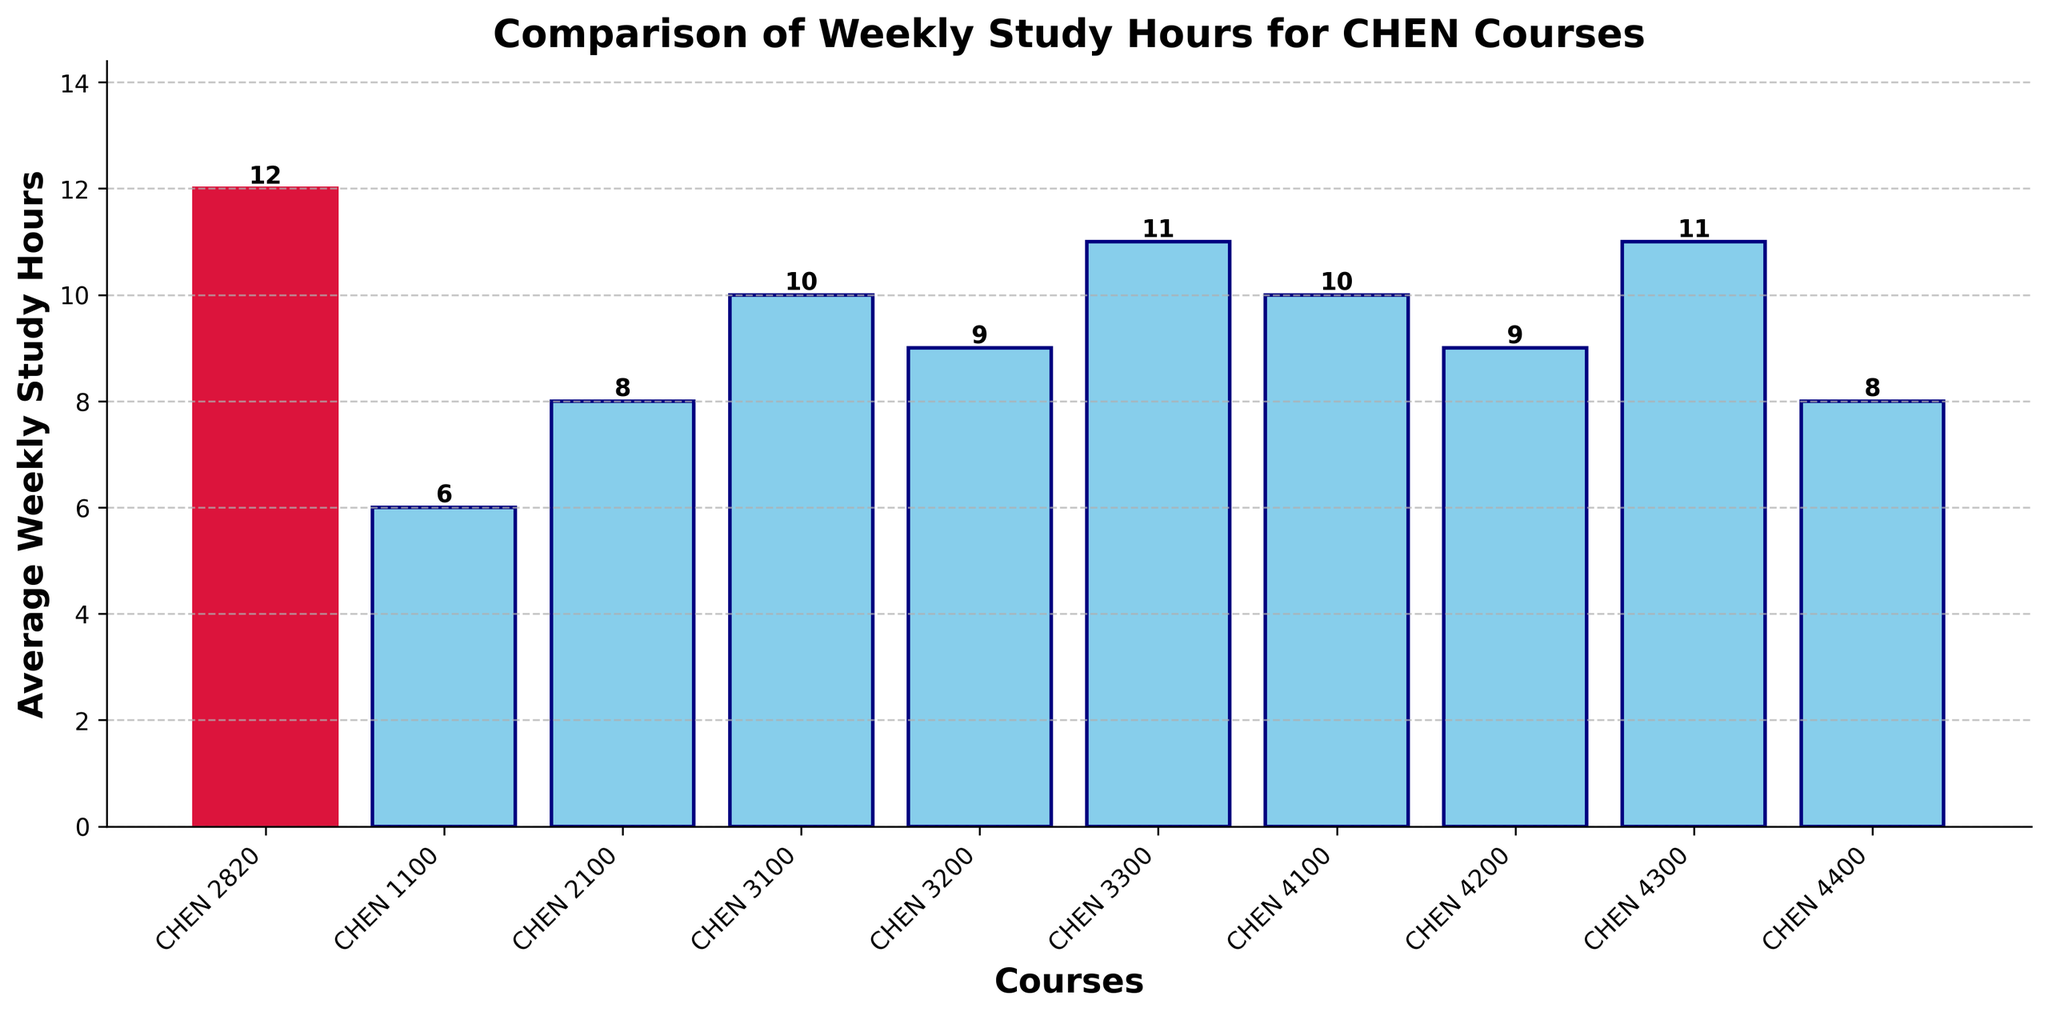What's the average number of study hours for CHEN 2100 and CHEN 4400 combined? Add the study hours of CHEN 2100 (8 hours) and CHEN 4400 (8 hours) to get 16 hours, then divide by 2 to get the average: 16/2 = 8 hours
Answer: 8 hours Which course requires more study hours: CHEN 4200 or CHEN 3200? CHEN 4200 requires 9 hours while CHEN 3200 also requires 9 hours, so they are equal
Answer: They are equal How does the study time for CHEN 2820 compare to the course with the fewest study hours? CHEN 2820 requires 12 hours, whereas the course with the fewest study hours, CHEN 1100, requires 6 hours. The difference is 12 - 6 = 6 hours
Answer: 6 hours more Which bar is colored differently than the others, and what does it represent? The bar filled with a crimson color represents CHEN 2820. All other bars are in sky blue
Answer: CHEN 2820 What's the total study time for CHEN 3200, CHEN 3300, and CHEN 4100? Add the study hours of CHEN 3200 (9 hours), CHEN 3300 (11 hours), and CHEN 4100 (10 hours): 9 + 11 + 10 = 30 hours
Answer: 30 hours Is there any course with study hours equal to CHEN 3100? CHEN 3100 requires 10 hours. CHEN 4100 also requires 10 hours
Answer: CHEN 4100 How much higher is the study time for CHEN 2820 compared to the median study time of all courses? List all study hours: [6, 8, 8, 9, 9, 10, 10, 11, 11, 12]. The median is the average of the two middle values (9, 10), which is 9.5 hours. The difference is 12 - 9.5 = 2.5 hours
Answer: 2.5 hours higher Which two courses require the most study hours? CHEN 2820 requires 12 hours and both CHEN 3300 and CHEN 4300 require 11 hours. CHEN 2820 requires the most, followed by CHEN 3300 and CHEN 4300
Answer: CHEN 2820 and CHEN 3300/CHEN 4300 What's the cumulative study time for all courses except CHEN 2820? Sum all hours except CHEN 2820: 6 + 8 + 8 + 9 + 9 + 10 + 10 + 11 + 11 = 82 hours
Answer: 82 hours 